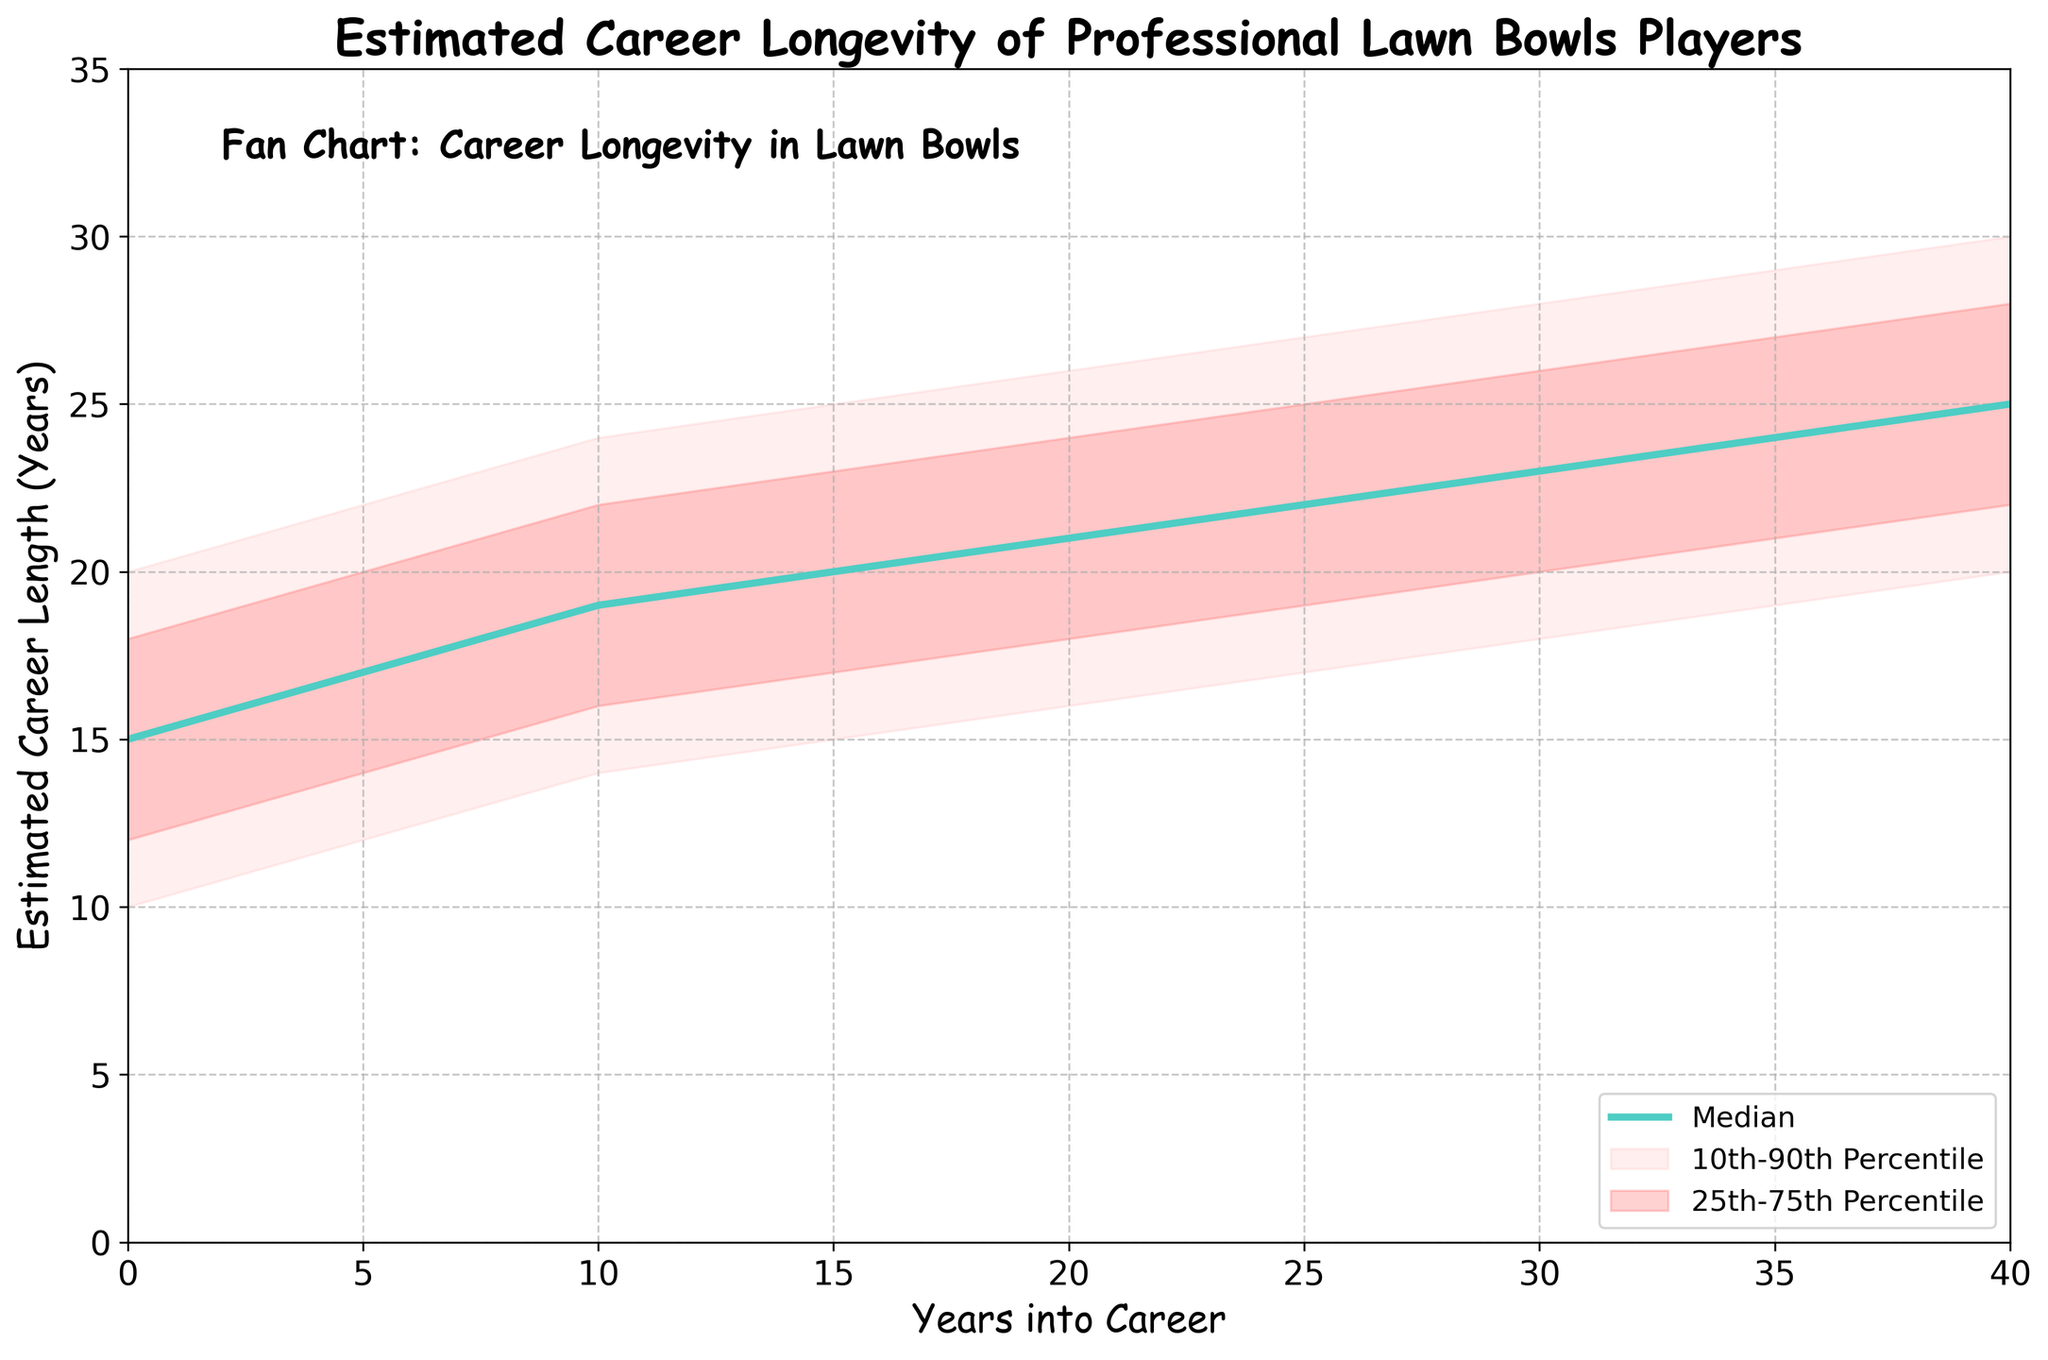What is the title of the fan chart? The title is usually located at the top of the chart, and in this case, it states: "Estimated Career Longevity of Professional Lawn Bowls Players".
Answer: Estimated Career Longevity of Professional Lawn Bowls Players What does the x-axis represent? The label on the x-axis indicates what is being measured or described along this axis. Here, it reads: "Years into Career".
Answer: Years into Career What is the median estimated career length for players at year 10? From the chart, you can follow the line labeled "Median" to the value at year 10. The plot shows the median estimated career length is 19 years.
Answer: 19 What's the estimated career longevity range for players at year 20 between the 25th and 75th percentiles? To find this, locate year 20 on the x-axis and then look between the shaded areas for the 25th and 75th percentiles. The values range from 18 to 24 years.
Answer: 18 to 24 years Does the estimated career length increase or decrease over time at the 90th percentile? By observing the topmost curve that represents the 90th percentile, it appears that the estimated career length increases from 20 years at the start to 30 years at year 40.
Answer: Increase What is the range for the estimated career longevity between the 10th and 90th percentiles at year 35? Locate year 35 on the x-axis and find the values corresponding to the 10th and 90th percentiles, which are 19 and 29 respectively, giving a range of 10 years.
Answer: 19 to 29 years How does the median career length change between year 0 and year 40? By looking at the median line at year 0 and year 40, you can see it starts at 15 years and increases to 25 years, indicating a 10-year increase.
Answer: Increases by 10 years What can be inferred about the variability in career longevity over time? The variability in career longevity can be assessed by the width of the shaded areas. The width increases over time, suggesting increasing variability in career lengths from initial to later career stages.
Answer: Increases over time Which percentile band is the widest at year 25? Compare the width of the bands at year 25. The band between the 10th and 90th percentiles is the widest.
Answer: 10th to 90th percentile 